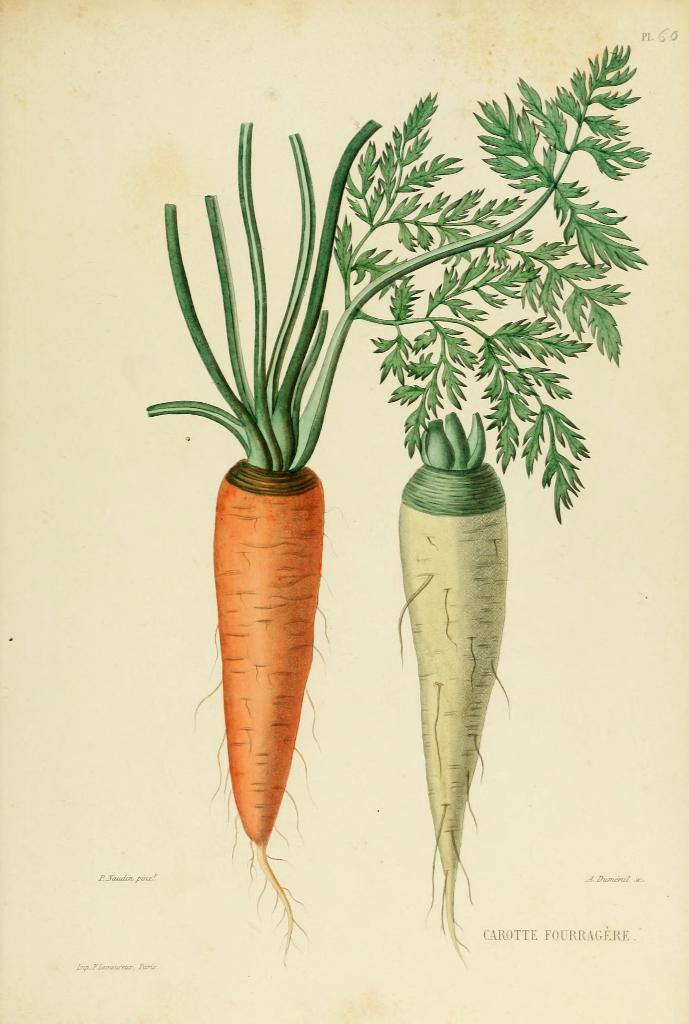What type of vegetables are depicted in the image? The image contains an art of a radish and an art of a carrot. How are the two vegetable arts arranged in the image? The art of the radish is beside the art of the carrot. How many chairs are depicted in the image? There are no chairs present in the image; it only contains the art of a radish and the art of a carrot. 